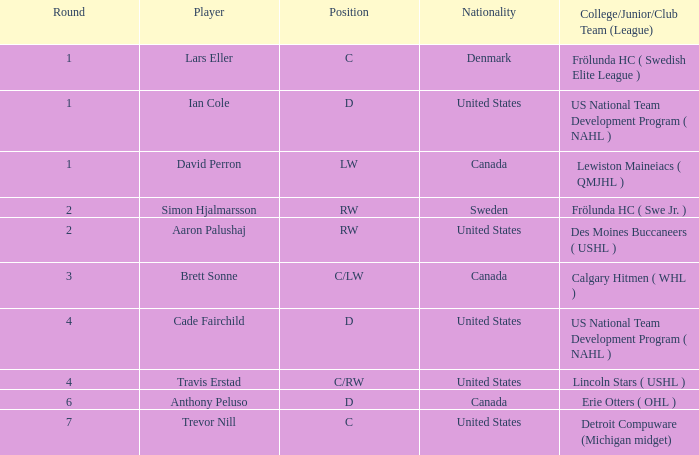Which college/junior/club team (league) was brett sonne a member of? Calgary Hitmen ( WHL ). 